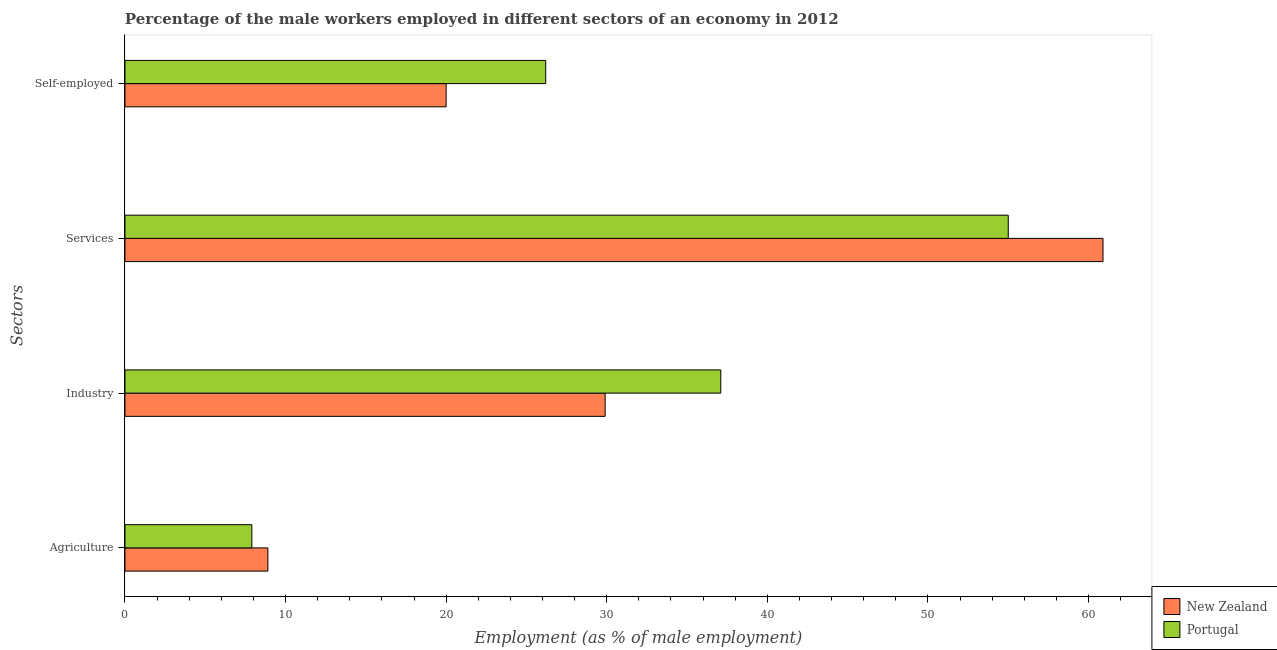How many different coloured bars are there?
Your answer should be compact. 2. Are the number of bars per tick equal to the number of legend labels?
Keep it short and to the point. Yes. Are the number of bars on each tick of the Y-axis equal?
Provide a short and direct response. Yes. What is the label of the 1st group of bars from the top?
Ensure brevity in your answer.  Self-employed. Across all countries, what is the maximum percentage of male workers in agriculture?
Keep it short and to the point. 8.9. Across all countries, what is the minimum percentage of male workers in agriculture?
Your answer should be compact. 7.9. In which country was the percentage of self employed male workers minimum?
Keep it short and to the point. New Zealand. What is the total percentage of male workers in industry in the graph?
Provide a short and direct response. 67. What is the difference between the percentage of male workers in agriculture in New Zealand and that in Portugal?
Provide a short and direct response. 1. What is the difference between the percentage of self employed male workers in Portugal and the percentage of male workers in services in New Zealand?
Give a very brief answer. -34.7. What is the average percentage of male workers in agriculture per country?
Your response must be concise. 8.4. What is the difference between the percentage of male workers in services and percentage of self employed male workers in Portugal?
Make the answer very short. 28.8. What is the ratio of the percentage of male workers in agriculture in Portugal to that in New Zealand?
Keep it short and to the point. 0.89. What is the difference between the highest and the second highest percentage of self employed male workers?
Your answer should be very brief. 6.2. What is the difference between the highest and the lowest percentage of self employed male workers?
Your answer should be compact. 6.2. What does the 2nd bar from the top in Self-employed represents?
Ensure brevity in your answer.  New Zealand. What does the 1st bar from the bottom in Industry represents?
Your response must be concise. New Zealand. Are all the bars in the graph horizontal?
Provide a succinct answer. Yes. Are the values on the major ticks of X-axis written in scientific E-notation?
Provide a succinct answer. No. How many legend labels are there?
Provide a short and direct response. 2. What is the title of the graph?
Ensure brevity in your answer.  Percentage of the male workers employed in different sectors of an economy in 2012. What is the label or title of the X-axis?
Your answer should be compact. Employment (as % of male employment). What is the label or title of the Y-axis?
Offer a terse response. Sectors. What is the Employment (as % of male employment) of New Zealand in Agriculture?
Your answer should be compact. 8.9. What is the Employment (as % of male employment) of Portugal in Agriculture?
Offer a very short reply. 7.9. What is the Employment (as % of male employment) of New Zealand in Industry?
Keep it short and to the point. 29.9. What is the Employment (as % of male employment) in Portugal in Industry?
Offer a terse response. 37.1. What is the Employment (as % of male employment) in New Zealand in Services?
Your answer should be very brief. 60.9. What is the Employment (as % of male employment) in Portugal in Self-employed?
Your answer should be compact. 26.2. Across all Sectors, what is the maximum Employment (as % of male employment) of New Zealand?
Your answer should be compact. 60.9. Across all Sectors, what is the minimum Employment (as % of male employment) of New Zealand?
Your answer should be very brief. 8.9. Across all Sectors, what is the minimum Employment (as % of male employment) in Portugal?
Your response must be concise. 7.9. What is the total Employment (as % of male employment) of New Zealand in the graph?
Offer a terse response. 119.7. What is the total Employment (as % of male employment) of Portugal in the graph?
Your answer should be compact. 126.2. What is the difference between the Employment (as % of male employment) of Portugal in Agriculture and that in Industry?
Provide a succinct answer. -29.2. What is the difference between the Employment (as % of male employment) of New Zealand in Agriculture and that in Services?
Your response must be concise. -52. What is the difference between the Employment (as % of male employment) of Portugal in Agriculture and that in Services?
Keep it short and to the point. -47.1. What is the difference between the Employment (as % of male employment) of Portugal in Agriculture and that in Self-employed?
Ensure brevity in your answer.  -18.3. What is the difference between the Employment (as % of male employment) of New Zealand in Industry and that in Services?
Ensure brevity in your answer.  -31. What is the difference between the Employment (as % of male employment) in Portugal in Industry and that in Services?
Your response must be concise. -17.9. What is the difference between the Employment (as % of male employment) in New Zealand in Industry and that in Self-employed?
Offer a terse response. 9.9. What is the difference between the Employment (as % of male employment) in New Zealand in Services and that in Self-employed?
Offer a terse response. 40.9. What is the difference between the Employment (as % of male employment) in Portugal in Services and that in Self-employed?
Your answer should be compact. 28.8. What is the difference between the Employment (as % of male employment) in New Zealand in Agriculture and the Employment (as % of male employment) in Portugal in Industry?
Offer a terse response. -28.2. What is the difference between the Employment (as % of male employment) of New Zealand in Agriculture and the Employment (as % of male employment) of Portugal in Services?
Offer a terse response. -46.1. What is the difference between the Employment (as % of male employment) of New Zealand in Agriculture and the Employment (as % of male employment) of Portugal in Self-employed?
Ensure brevity in your answer.  -17.3. What is the difference between the Employment (as % of male employment) in New Zealand in Industry and the Employment (as % of male employment) in Portugal in Services?
Provide a succinct answer. -25.1. What is the difference between the Employment (as % of male employment) in New Zealand in Industry and the Employment (as % of male employment) in Portugal in Self-employed?
Provide a short and direct response. 3.7. What is the difference between the Employment (as % of male employment) of New Zealand in Services and the Employment (as % of male employment) of Portugal in Self-employed?
Your answer should be very brief. 34.7. What is the average Employment (as % of male employment) in New Zealand per Sectors?
Your response must be concise. 29.93. What is the average Employment (as % of male employment) of Portugal per Sectors?
Your response must be concise. 31.55. What is the difference between the Employment (as % of male employment) in New Zealand and Employment (as % of male employment) in Portugal in Agriculture?
Give a very brief answer. 1. What is the difference between the Employment (as % of male employment) in New Zealand and Employment (as % of male employment) in Portugal in Services?
Provide a short and direct response. 5.9. What is the difference between the Employment (as % of male employment) of New Zealand and Employment (as % of male employment) of Portugal in Self-employed?
Your response must be concise. -6.2. What is the ratio of the Employment (as % of male employment) of New Zealand in Agriculture to that in Industry?
Your answer should be very brief. 0.3. What is the ratio of the Employment (as % of male employment) in Portugal in Agriculture to that in Industry?
Give a very brief answer. 0.21. What is the ratio of the Employment (as % of male employment) in New Zealand in Agriculture to that in Services?
Keep it short and to the point. 0.15. What is the ratio of the Employment (as % of male employment) of Portugal in Agriculture to that in Services?
Make the answer very short. 0.14. What is the ratio of the Employment (as % of male employment) of New Zealand in Agriculture to that in Self-employed?
Provide a succinct answer. 0.45. What is the ratio of the Employment (as % of male employment) in Portugal in Agriculture to that in Self-employed?
Make the answer very short. 0.3. What is the ratio of the Employment (as % of male employment) of New Zealand in Industry to that in Services?
Make the answer very short. 0.49. What is the ratio of the Employment (as % of male employment) in Portugal in Industry to that in Services?
Ensure brevity in your answer.  0.67. What is the ratio of the Employment (as % of male employment) of New Zealand in Industry to that in Self-employed?
Give a very brief answer. 1.5. What is the ratio of the Employment (as % of male employment) of Portugal in Industry to that in Self-employed?
Provide a succinct answer. 1.42. What is the ratio of the Employment (as % of male employment) of New Zealand in Services to that in Self-employed?
Your response must be concise. 3.04. What is the ratio of the Employment (as % of male employment) of Portugal in Services to that in Self-employed?
Provide a succinct answer. 2.1. What is the difference between the highest and the second highest Employment (as % of male employment) in New Zealand?
Provide a succinct answer. 31. What is the difference between the highest and the second highest Employment (as % of male employment) of Portugal?
Keep it short and to the point. 17.9. What is the difference between the highest and the lowest Employment (as % of male employment) of New Zealand?
Make the answer very short. 52. What is the difference between the highest and the lowest Employment (as % of male employment) of Portugal?
Offer a very short reply. 47.1. 